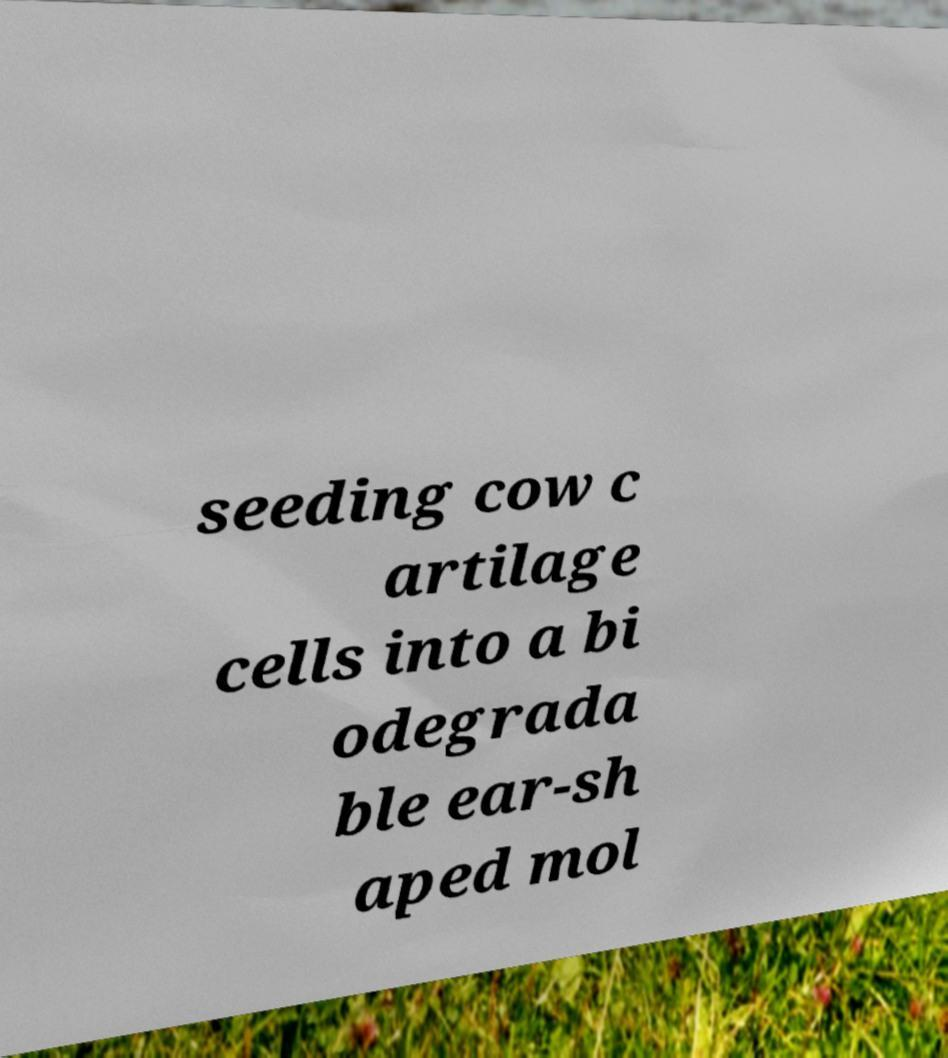Can you read and provide the text displayed in the image?This photo seems to have some interesting text. Can you extract and type it out for me? seeding cow c artilage cells into a bi odegrada ble ear-sh aped mol 